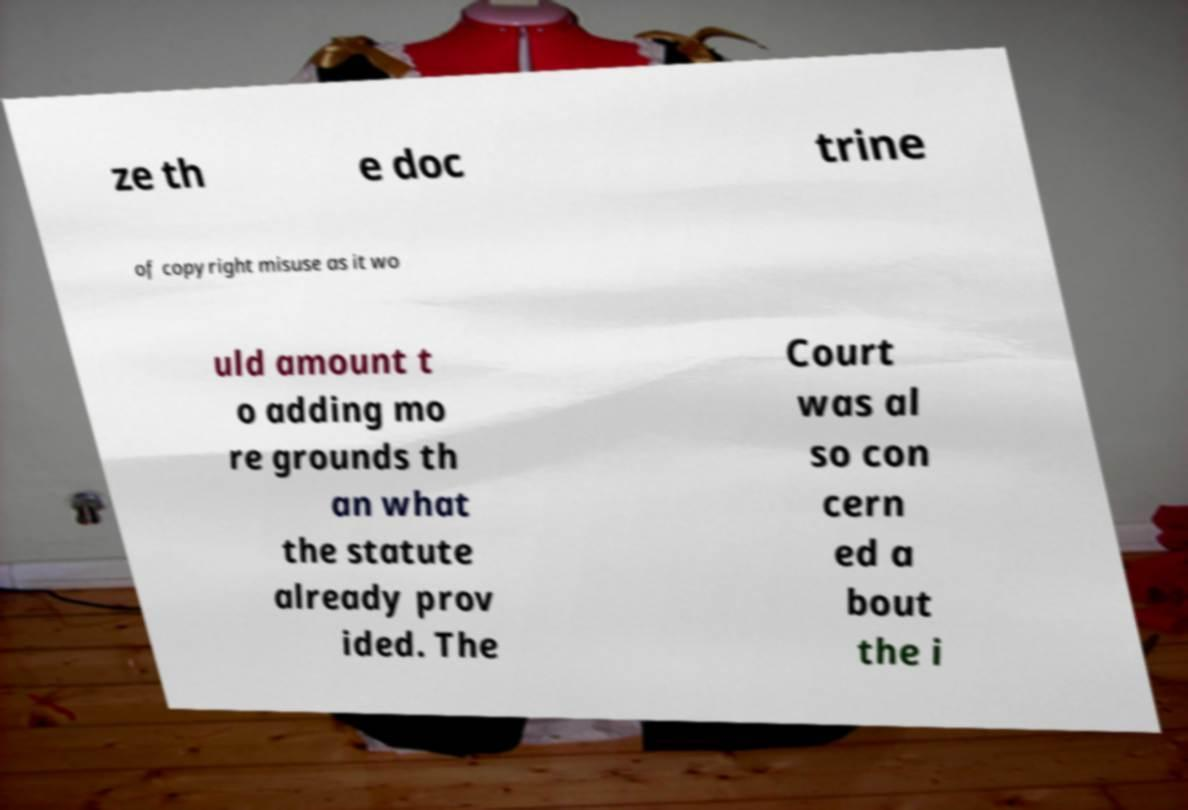For documentation purposes, I need the text within this image transcribed. Could you provide that? ze th e doc trine of copyright misuse as it wo uld amount t o adding mo re grounds th an what the statute already prov ided. The Court was al so con cern ed a bout the i 